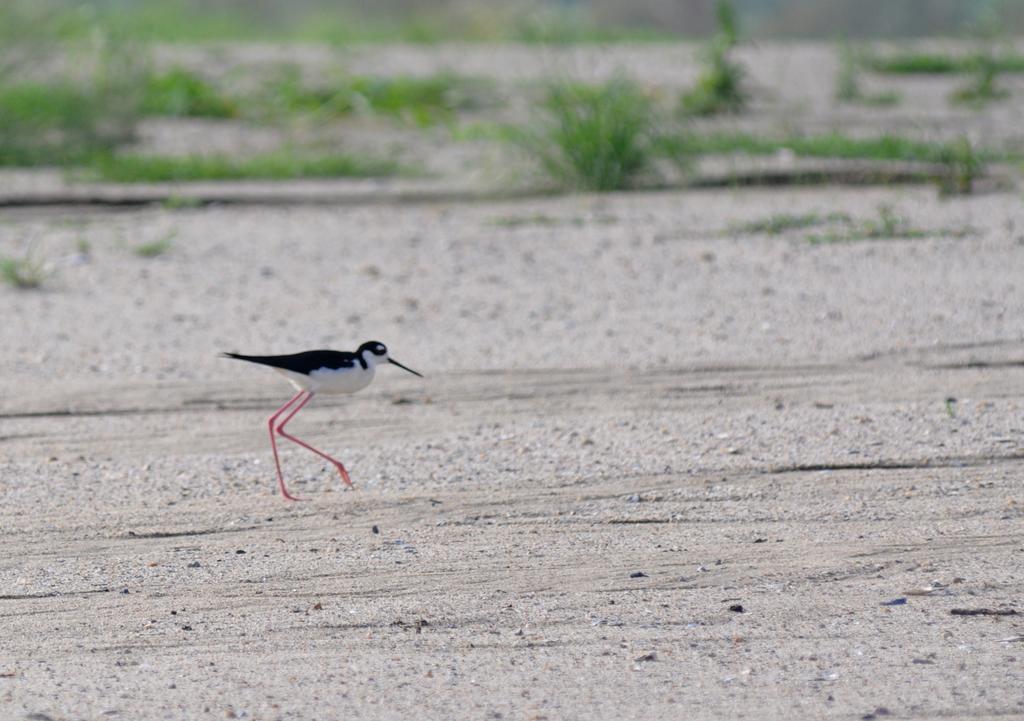How would you summarize this image in a sentence or two? In this image there are plants on the ground, there is a bird on the ground, there are plants truncated towards the left of the image, there are plants truncated towards the right of the image. 